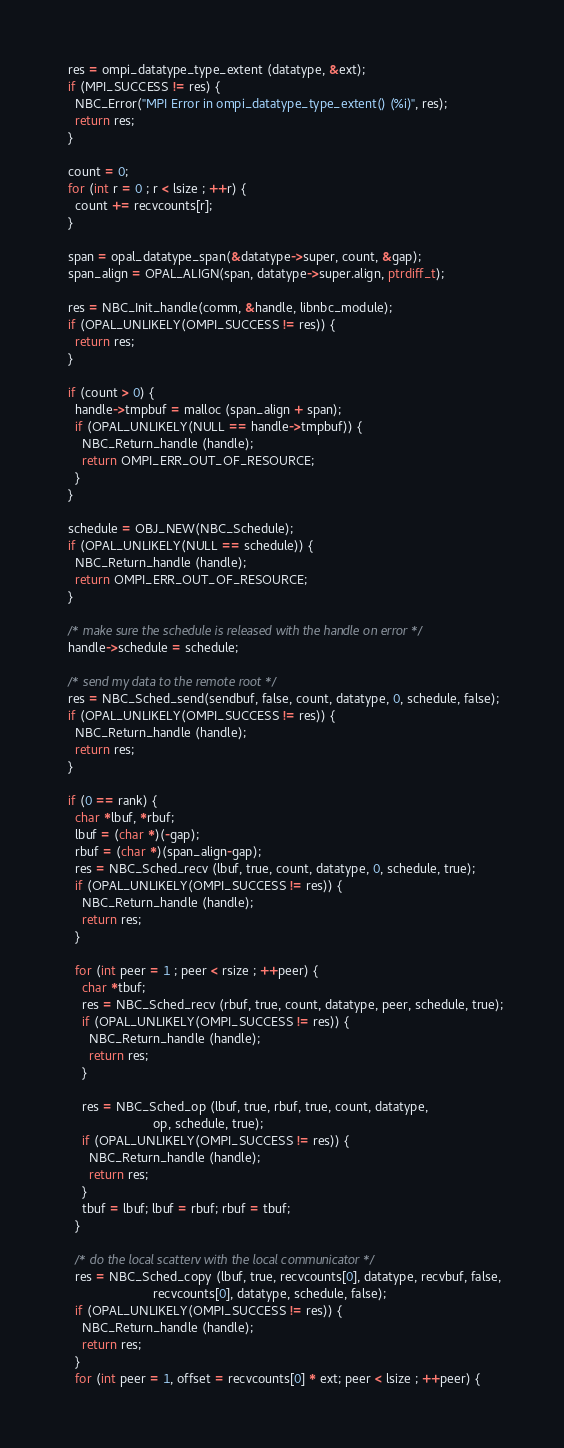Convert code to text. <code><loc_0><loc_0><loc_500><loc_500><_C_>  res = ompi_datatype_type_extent (datatype, &ext);
  if (MPI_SUCCESS != res) {
    NBC_Error("MPI Error in ompi_datatype_type_extent() (%i)", res);
    return res;
  }

  count = 0;
  for (int r = 0 ; r < lsize ; ++r) {
    count += recvcounts[r];
  }

  span = opal_datatype_span(&datatype->super, count, &gap);
  span_align = OPAL_ALIGN(span, datatype->super.align, ptrdiff_t);

  res = NBC_Init_handle(comm, &handle, libnbc_module);
  if (OPAL_UNLIKELY(OMPI_SUCCESS != res)) {
    return res;
  }

  if (count > 0) {
    handle->tmpbuf = malloc (span_align + span);
    if (OPAL_UNLIKELY(NULL == handle->tmpbuf)) {
      NBC_Return_handle (handle);
      return OMPI_ERR_OUT_OF_RESOURCE;
    }
  }

  schedule = OBJ_NEW(NBC_Schedule);
  if (OPAL_UNLIKELY(NULL == schedule)) {
    NBC_Return_handle (handle);
    return OMPI_ERR_OUT_OF_RESOURCE;
  }

  /* make sure the schedule is released with the handle on error */
  handle->schedule = schedule;

  /* send my data to the remote root */
  res = NBC_Sched_send(sendbuf, false, count, datatype, 0, schedule, false);
  if (OPAL_UNLIKELY(OMPI_SUCCESS != res)) {
    NBC_Return_handle (handle);
    return res;
  }

  if (0 == rank) {
    char *lbuf, *rbuf;
    lbuf = (char *)(-gap);
    rbuf = (char *)(span_align-gap);
    res = NBC_Sched_recv (lbuf, true, count, datatype, 0, schedule, true);
    if (OPAL_UNLIKELY(OMPI_SUCCESS != res)) {
      NBC_Return_handle (handle);
      return res;
    }

    for (int peer = 1 ; peer < rsize ; ++peer) {
      char *tbuf;
      res = NBC_Sched_recv (rbuf, true, count, datatype, peer, schedule, true);
      if (OPAL_UNLIKELY(OMPI_SUCCESS != res)) {
        NBC_Return_handle (handle);
        return res;
      }

      res = NBC_Sched_op (lbuf, true, rbuf, true, count, datatype,
                          op, schedule, true);
      if (OPAL_UNLIKELY(OMPI_SUCCESS != res)) {
        NBC_Return_handle (handle);
        return res;
      }
      tbuf = lbuf; lbuf = rbuf; rbuf = tbuf;
    }

    /* do the local scatterv with the local communicator */
    res = NBC_Sched_copy (lbuf, true, recvcounts[0], datatype, recvbuf, false,
                          recvcounts[0], datatype, schedule, false);
    if (OPAL_UNLIKELY(OMPI_SUCCESS != res)) {
      NBC_Return_handle (handle);
      return res;
    }
    for (int peer = 1, offset = recvcounts[0] * ext; peer < lsize ; ++peer) {</code> 